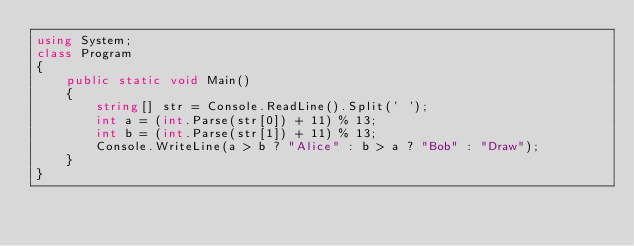<code> <loc_0><loc_0><loc_500><loc_500><_C#_>using System;
class Program
{
    public static void Main()
    {
        string[] str = Console.ReadLine().Split(' ');
        int a = (int.Parse(str[0]) + 11) % 13;
        int b = (int.Parse(str[1]) + 11) % 13;
        Console.WriteLine(a > b ? "Alice" : b > a ? "Bob" : "Draw");
    }
}</code> 